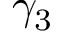Convert formula to latex. <formula><loc_0><loc_0><loc_500><loc_500>\gamma _ { 3 }</formula> 